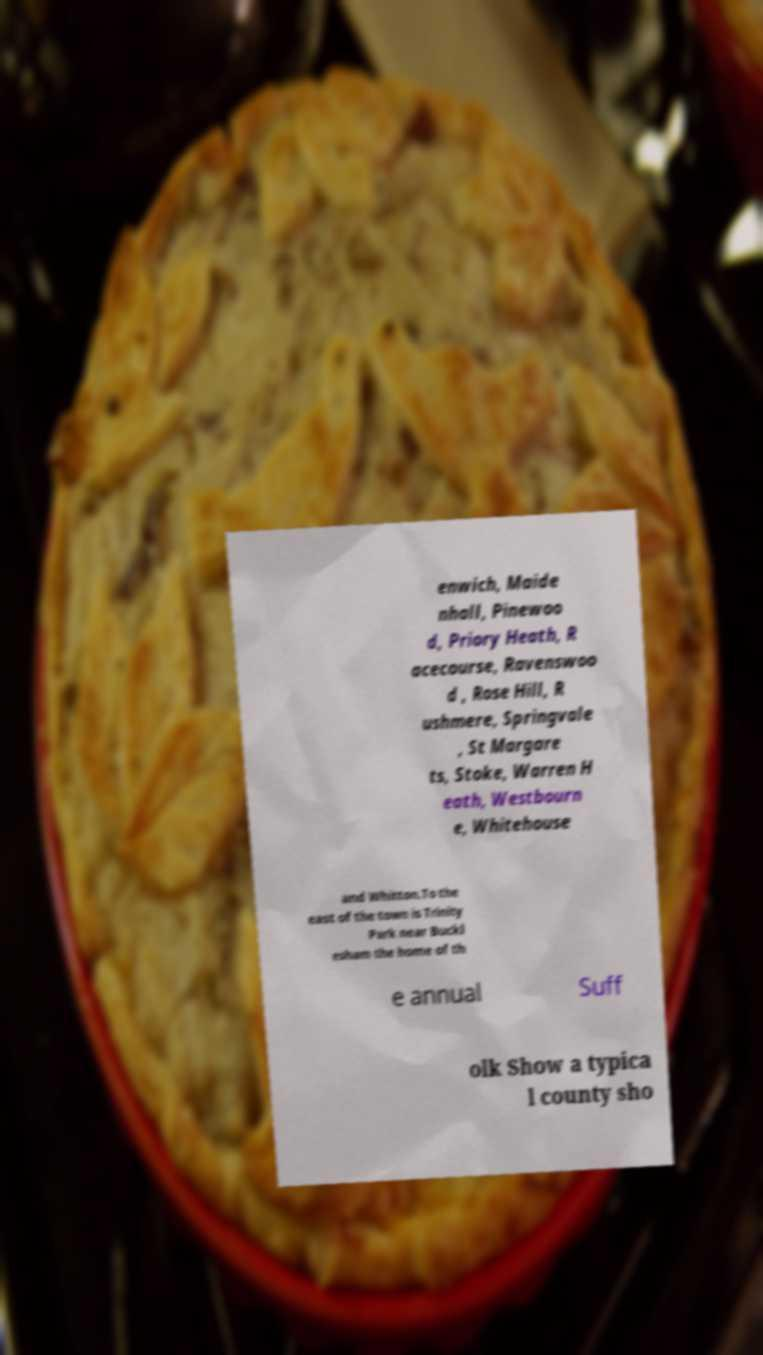Please identify and transcribe the text found in this image. enwich, Maide nhall, Pinewoo d, Priory Heath, R acecourse, Ravenswoo d , Rose Hill, R ushmere, Springvale , St Margare ts, Stoke, Warren H eath, Westbourn e, Whitehouse and Whitton.To the east of the town is Trinity Park near Buckl esham the home of th e annual Suff olk Show a typica l county sho 